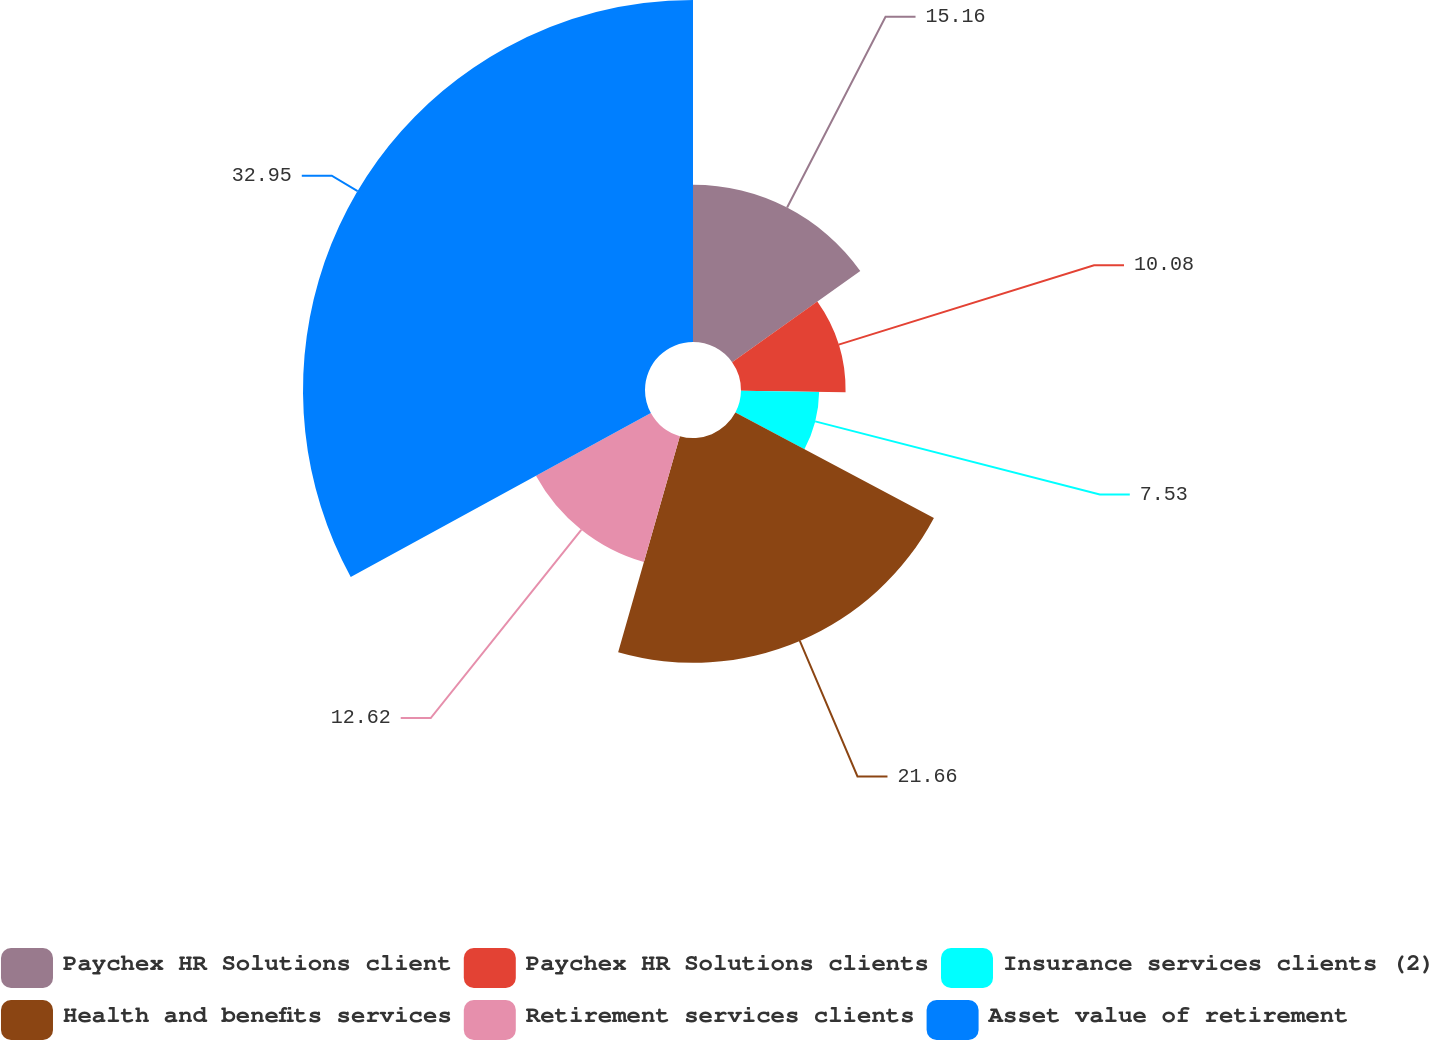Convert chart. <chart><loc_0><loc_0><loc_500><loc_500><pie_chart><fcel>Paychex HR Solutions client<fcel>Paychex HR Solutions clients<fcel>Insurance services clients (2)<fcel>Health and benefits services<fcel>Retirement services clients<fcel>Asset value of retirement<nl><fcel>15.16%<fcel>10.08%<fcel>7.53%<fcel>21.66%<fcel>12.62%<fcel>32.96%<nl></chart> 